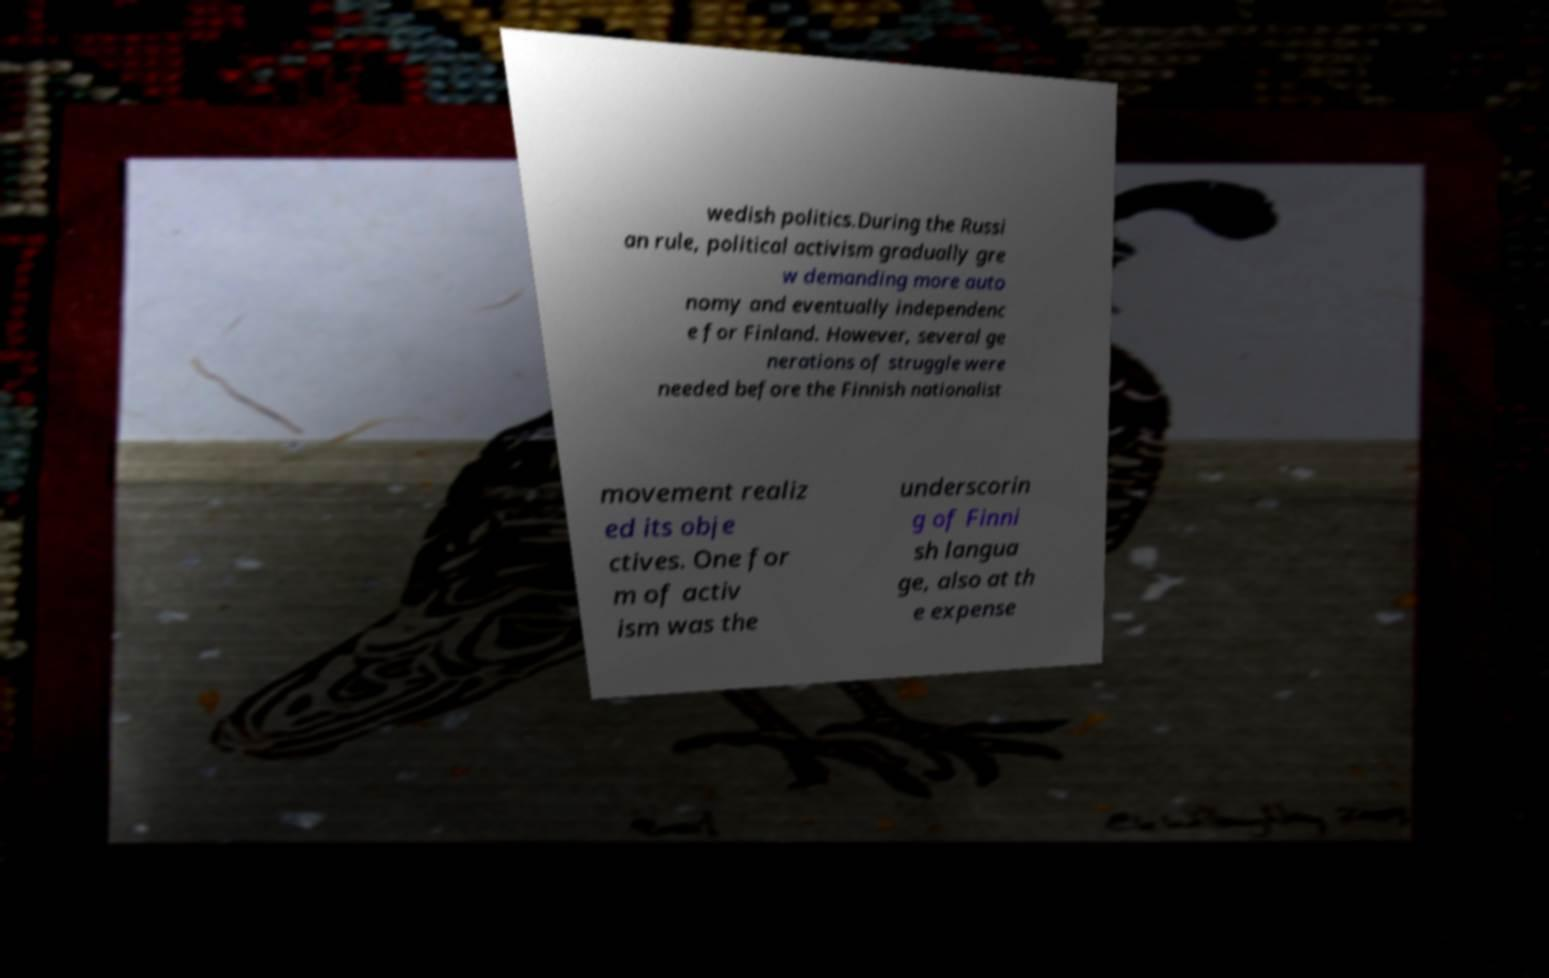Please read and relay the text visible in this image. What does it say? wedish politics.During the Russi an rule, political activism gradually gre w demanding more auto nomy and eventually independenc e for Finland. However, several ge nerations of struggle were needed before the Finnish nationalist movement realiz ed its obje ctives. One for m of activ ism was the underscorin g of Finni sh langua ge, also at th e expense 